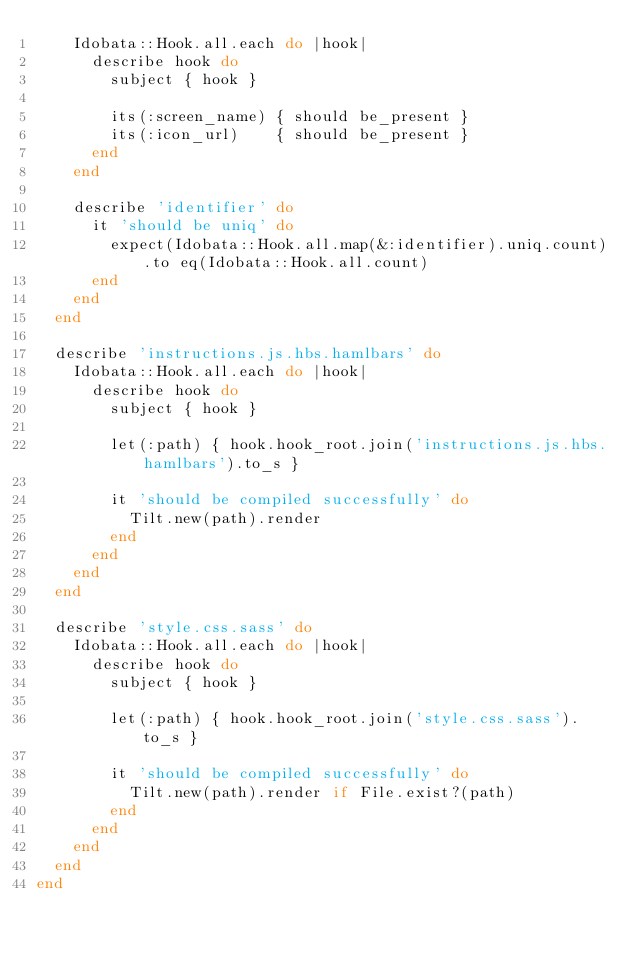Convert code to text. <code><loc_0><loc_0><loc_500><loc_500><_Ruby_>    Idobata::Hook.all.each do |hook|
      describe hook do
        subject { hook }

        its(:screen_name) { should be_present }
        its(:icon_url)    { should be_present }
      end
    end

    describe 'identifier' do
      it 'should be uniq' do
        expect(Idobata::Hook.all.map(&:identifier).uniq.count).to eq(Idobata::Hook.all.count)
      end
    end
  end

  describe 'instructions.js.hbs.hamlbars' do
    Idobata::Hook.all.each do |hook|
      describe hook do
        subject { hook }

        let(:path) { hook.hook_root.join('instructions.js.hbs.hamlbars').to_s }

        it 'should be compiled successfully' do
          Tilt.new(path).render
        end
      end
    end
  end

  describe 'style.css.sass' do
    Idobata::Hook.all.each do |hook|
      describe hook do
        subject { hook }

        let(:path) { hook.hook_root.join('style.css.sass').to_s }

        it 'should be compiled successfully' do
          Tilt.new(path).render if File.exist?(path)
        end
      end
    end
  end
end
</code> 